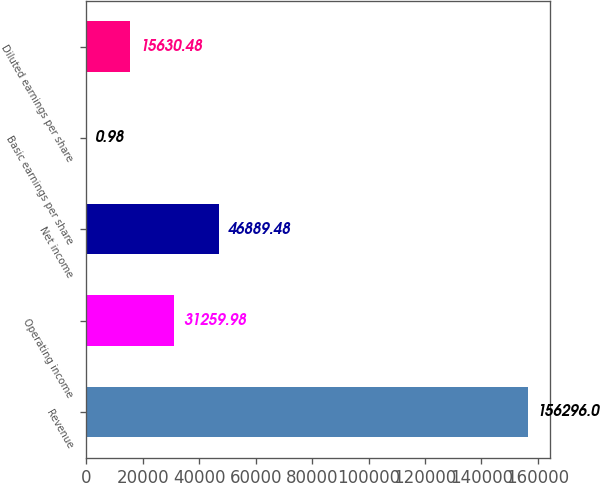Convert chart to OTSL. <chart><loc_0><loc_0><loc_500><loc_500><bar_chart><fcel>Revenue<fcel>Operating income<fcel>Net income<fcel>Basic earnings per share<fcel>Diluted earnings per share<nl><fcel>156296<fcel>31260<fcel>46889.5<fcel>0.98<fcel>15630.5<nl></chart> 